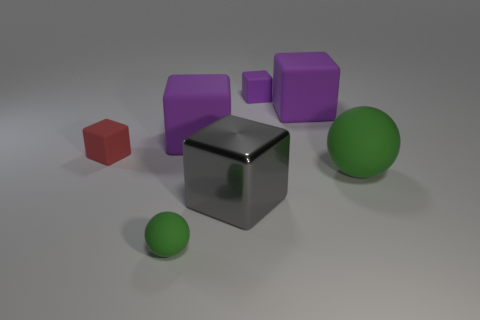Can you describe the lighting in the scene? The lighting in this scene is soft and diffuse, suggesting an overcast sky or a large, distant light source. The shadows on the ground are soft and do not have sharp edges, which reinforces the idea of diffused lighting. The reflections on the metallic cube and the subtle light gradients on all objects indicate a well-lit environment without harsh direct light. 